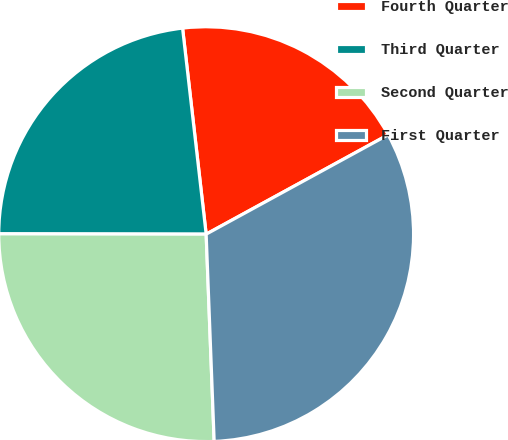Convert chart to OTSL. <chart><loc_0><loc_0><loc_500><loc_500><pie_chart><fcel>Fourth Quarter<fcel>Third Quarter<fcel>Second Quarter<fcel>First Quarter<nl><fcel>18.86%<fcel>23.16%<fcel>25.64%<fcel>32.34%<nl></chart> 